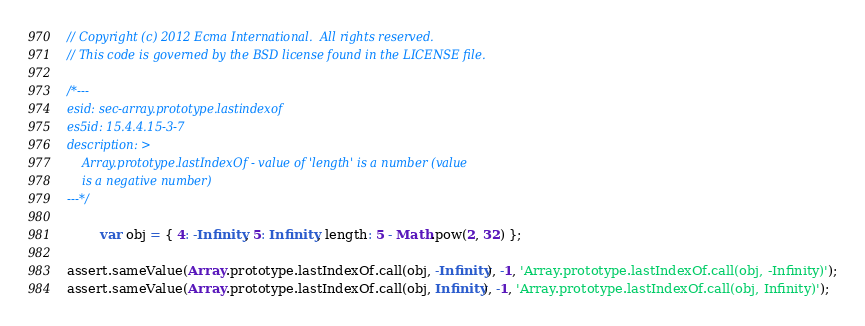<code> <loc_0><loc_0><loc_500><loc_500><_JavaScript_>// Copyright (c) 2012 Ecma International.  All rights reserved.
// This code is governed by the BSD license found in the LICENSE file.

/*---
esid: sec-array.prototype.lastindexof
es5id: 15.4.4.15-3-7
description: >
    Array.prototype.lastIndexOf - value of 'length' is a number (value
    is a negative number)
---*/

        var obj = { 4: -Infinity, 5: Infinity, length: 5 - Math.pow(2, 32) };

assert.sameValue(Array.prototype.lastIndexOf.call(obj, -Infinity), -1, 'Array.prototype.lastIndexOf.call(obj, -Infinity)');
assert.sameValue(Array.prototype.lastIndexOf.call(obj, Infinity), -1, 'Array.prototype.lastIndexOf.call(obj, Infinity)');
</code> 